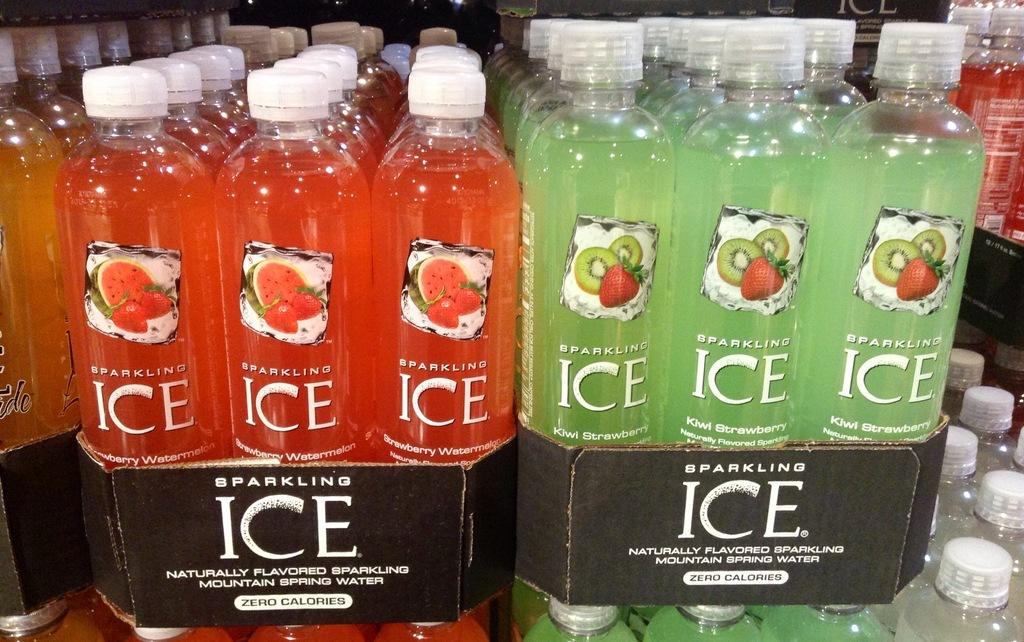<image>
Provide a brief description of the given image. A few bottles of Sparkling Ice in boxes 